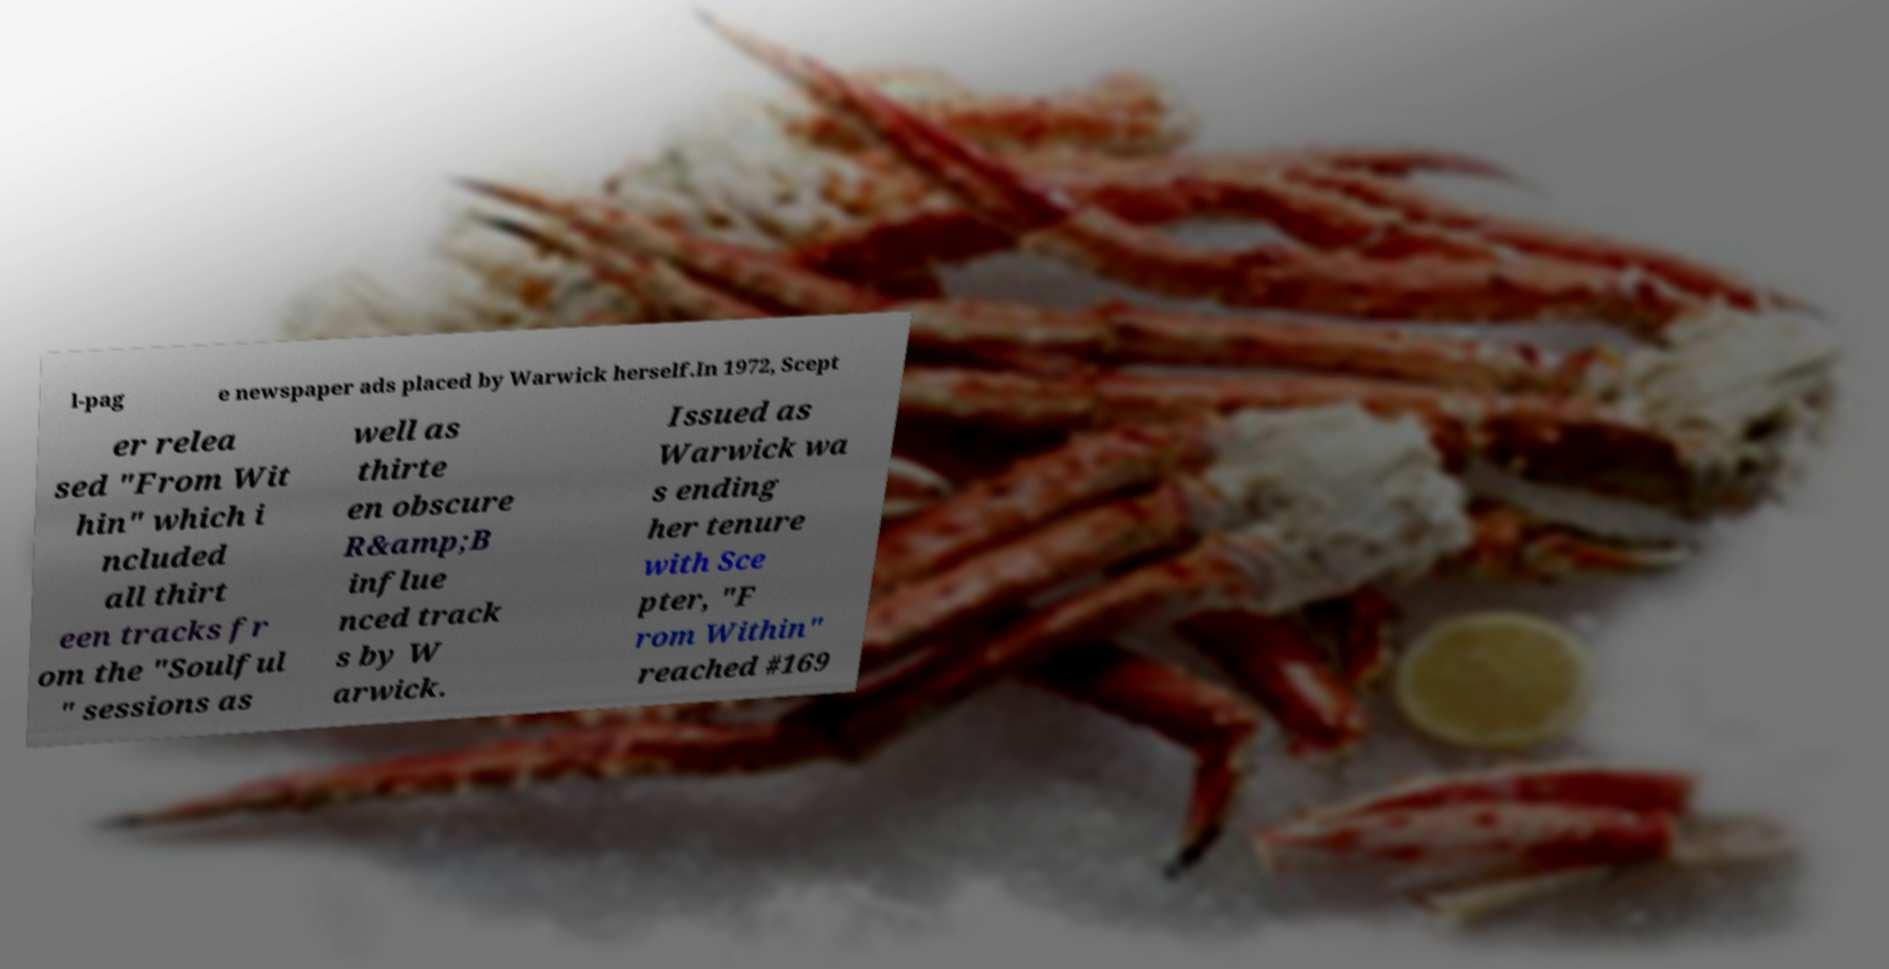What messages or text are displayed in this image? I need them in a readable, typed format. l-pag e newspaper ads placed by Warwick herself.In 1972, Scept er relea sed "From Wit hin" which i ncluded all thirt een tracks fr om the "Soulful " sessions as well as thirte en obscure R&amp;B influe nced track s by W arwick. Issued as Warwick wa s ending her tenure with Sce pter, "F rom Within" reached #169 